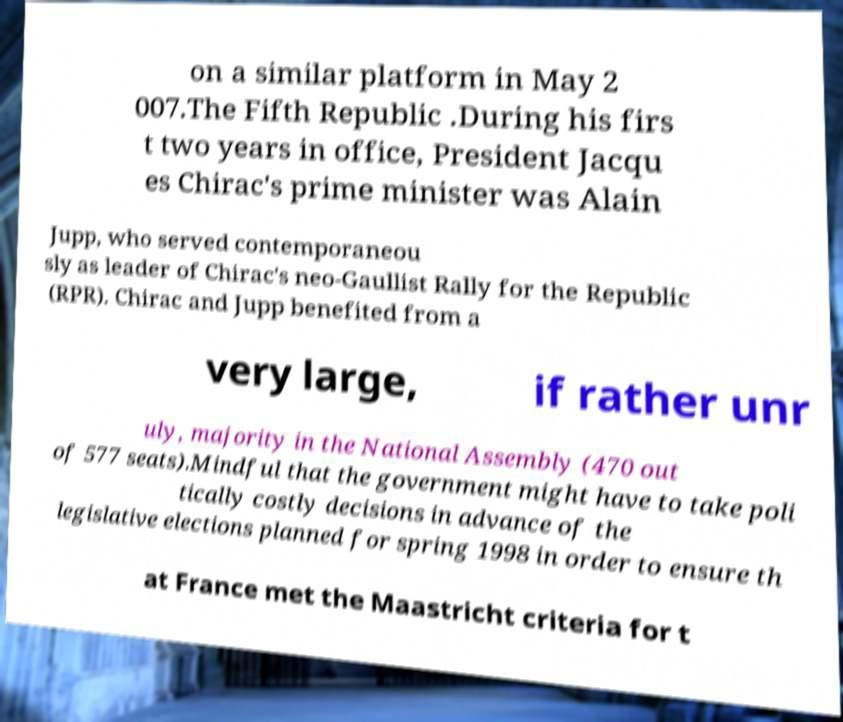Could you assist in decoding the text presented in this image and type it out clearly? on a similar platform in May 2 007.The Fifth Republic .During his firs t two years in office, President Jacqu es Chirac's prime minister was Alain Jupp, who served contemporaneou sly as leader of Chirac's neo-Gaullist Rally for the Republic (RPR). Chirac and Jupp benefited from a very large, if rather unr uly, majority in the National Assembly (470 out of 577 seats).Mindful that the government might have to take poli tically costly decisions in advance of the legislative elections planned for spring 1998 in order to ensure th at France met the Maastricht criteria for t 